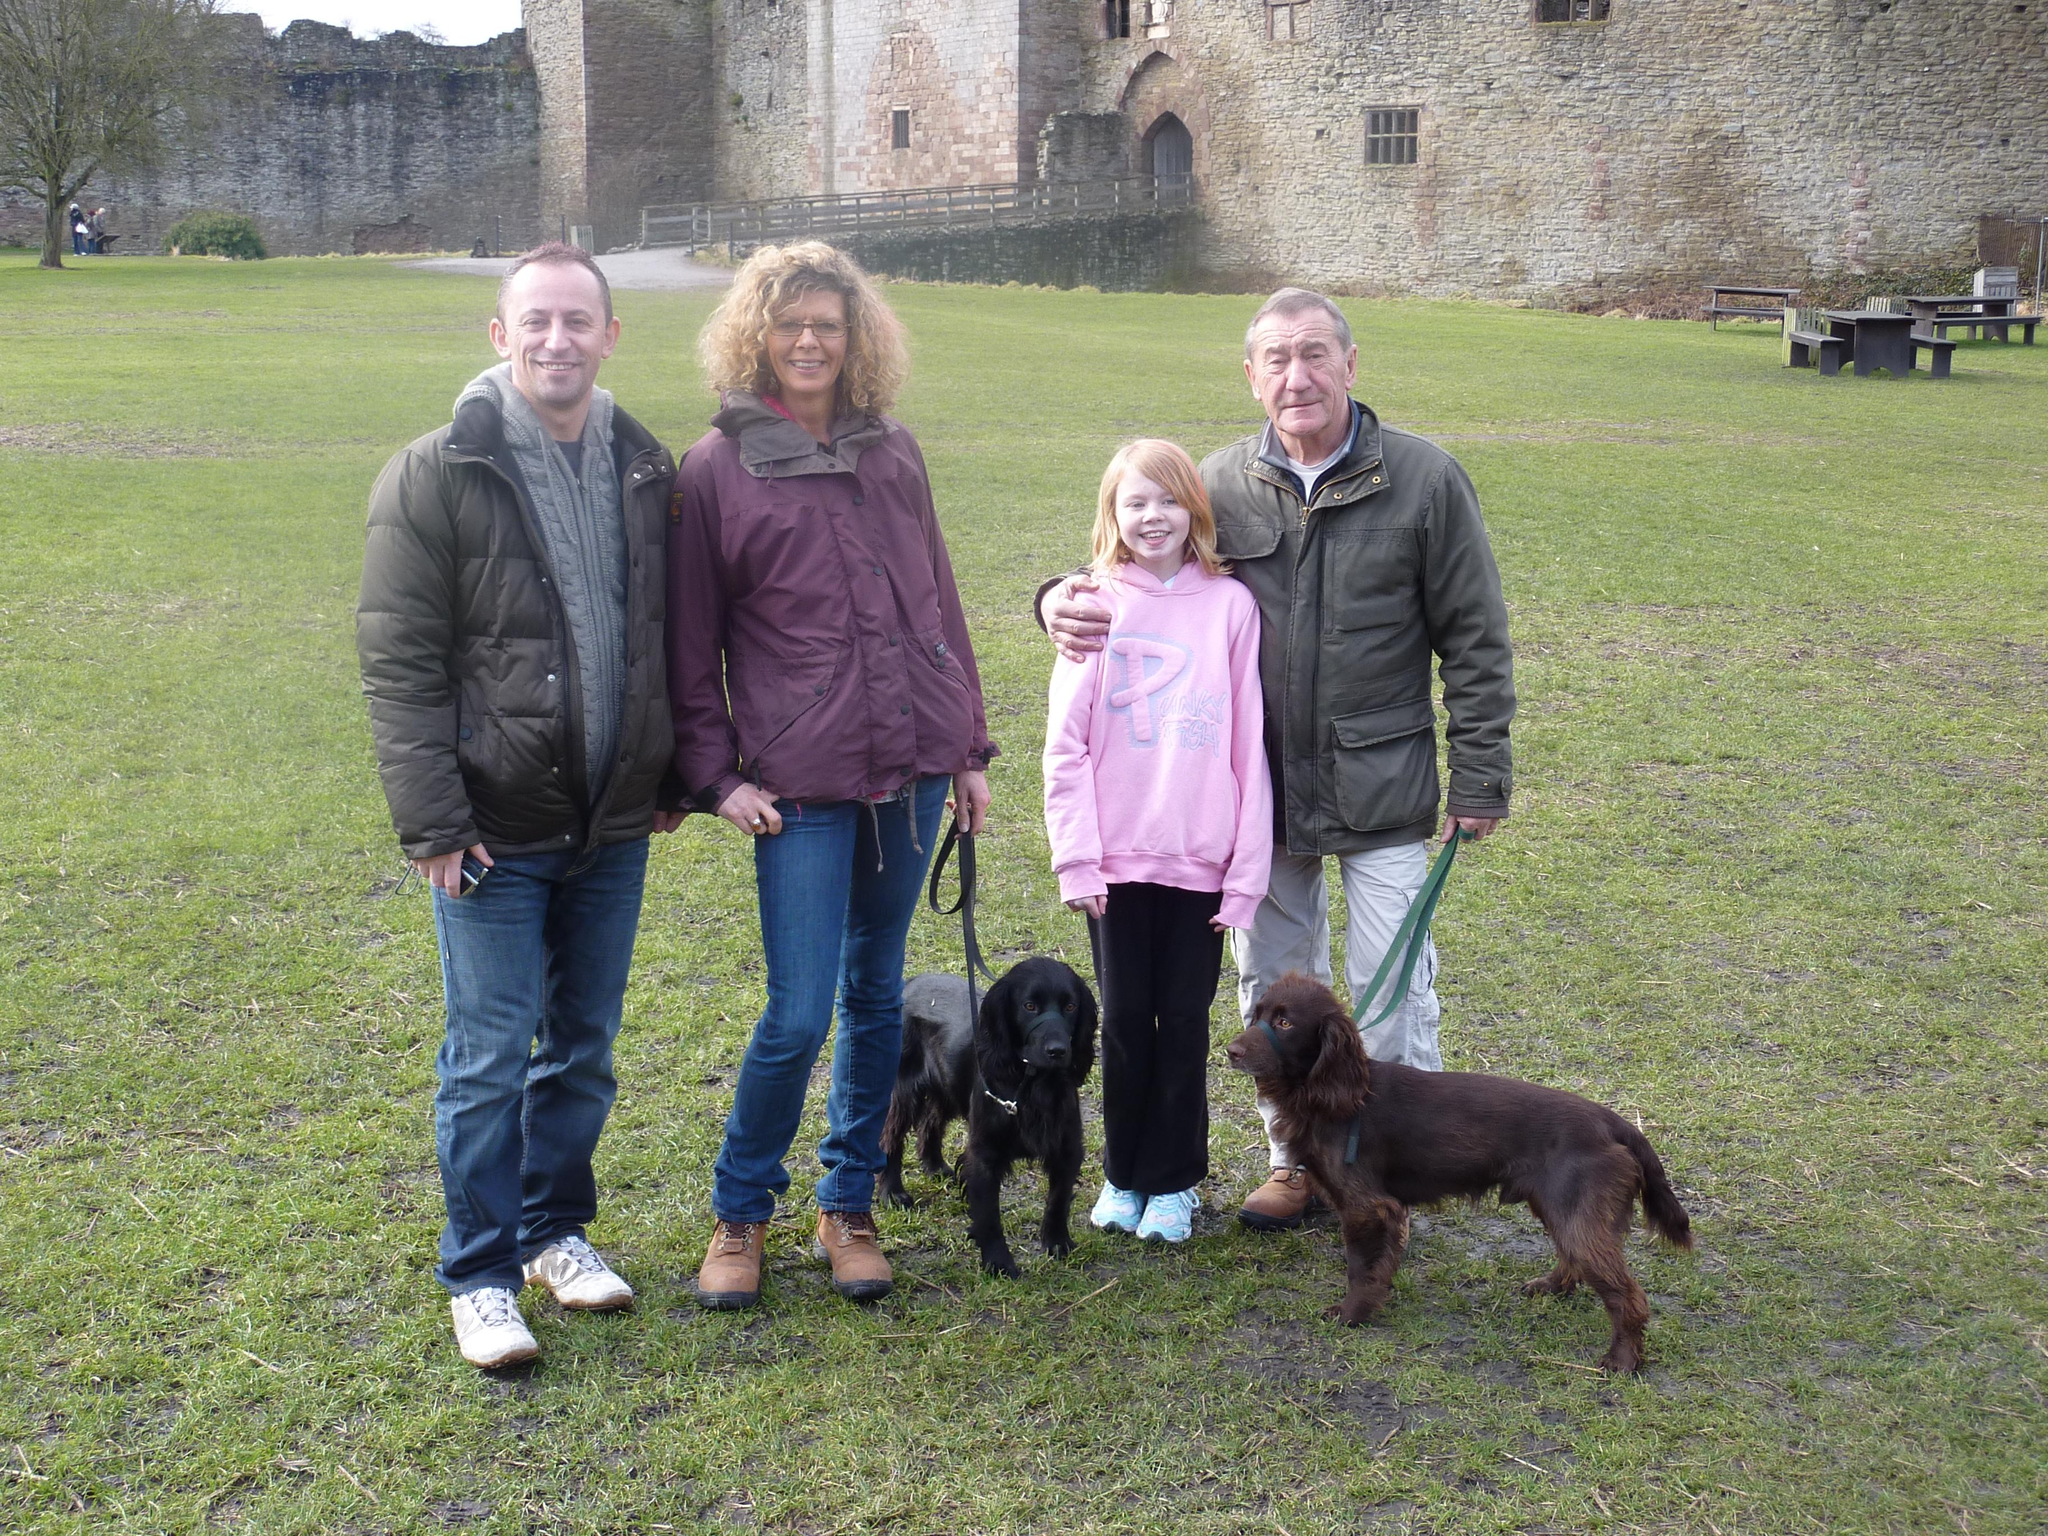What is happening in the image? There are people standing with two dogs in the image. What can be seen in the background of the image? There is a tree and a building in the background of the image. How are the people in the image feeling? The people in the image have smiles on their faces, indicating they are happy or enjoying themselves. What type of nut is being used as a hat by one of the dogs in the image? There is no nut present in the image, and neither dog is wearing a hat. 